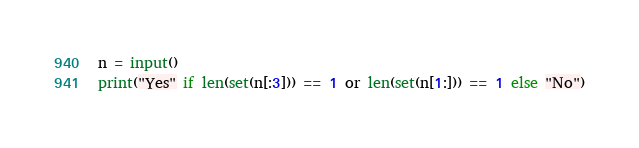Convert code to text. <code><loc_0><loc_0><loc_500><loc_500><_Python_>n = input()
print("Yes" if len(set(n[:3])) == 1 or len(set(n[1:])) == 1 else "No")</code> 